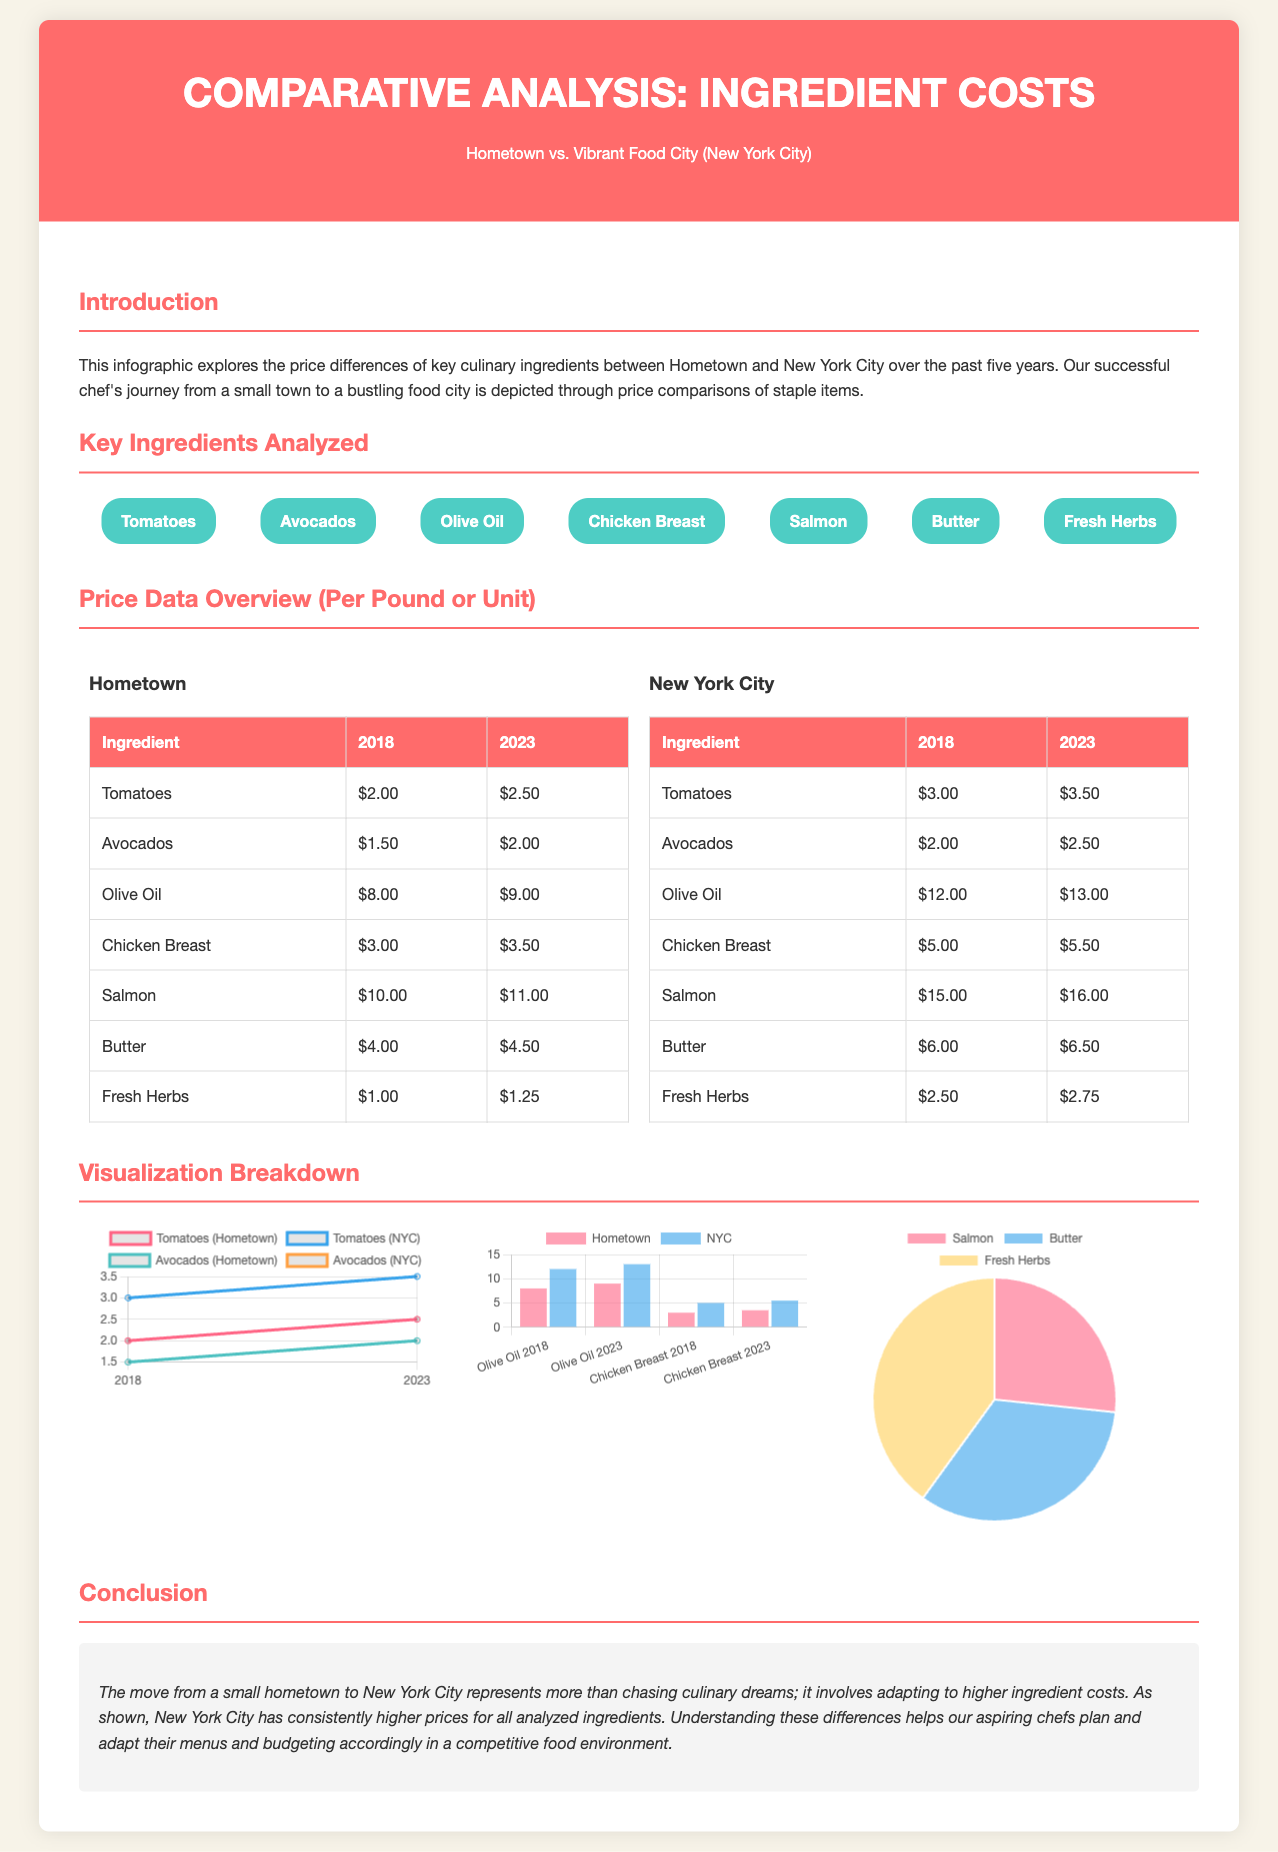What was the price of tomatoes in Hometown in 2018? The price of tomatoes in Hometown in 2018 is listed in the price data overview section.
Answer: $2.00 What ingredient had the highest price increase in NYC between 2018 and 2023? The ingredient with the highest price increase can be determined by comparing the differences in prices between the two years for each ingredient.
Answer: Salmon What was the price of olive oil in NYC in 2023? The price of olive oil in NYC in 2023 is specified in the price data overview table.
Answer: $13.00 Which two ingredients are compared in the line chart? The line chart depicts price changes for two specific ingredients over time.
Answer: Tomatoes and Avocados What is the total price of butter in Hometown in 2023? The total price of butter for Hometown in 2023 can be found in the price comparison table.
Answer: $4.50 How much were avocados in Hometown in 2023? The prices of avocados for Hometown in 2023 are detailed in the price data overview.
Answer: $2.00 What type of chart illustrates the percentage increase in NYC? The type of chart used to show the percentage increase for various ingredients is mentioned in the visualization breakdown section.
Answer: Pie Chart What is the purpose of this infographic? The purpose is outlined in the introduction, highlighting the comparison of ingredient prices.
Answer: To explore price differences 